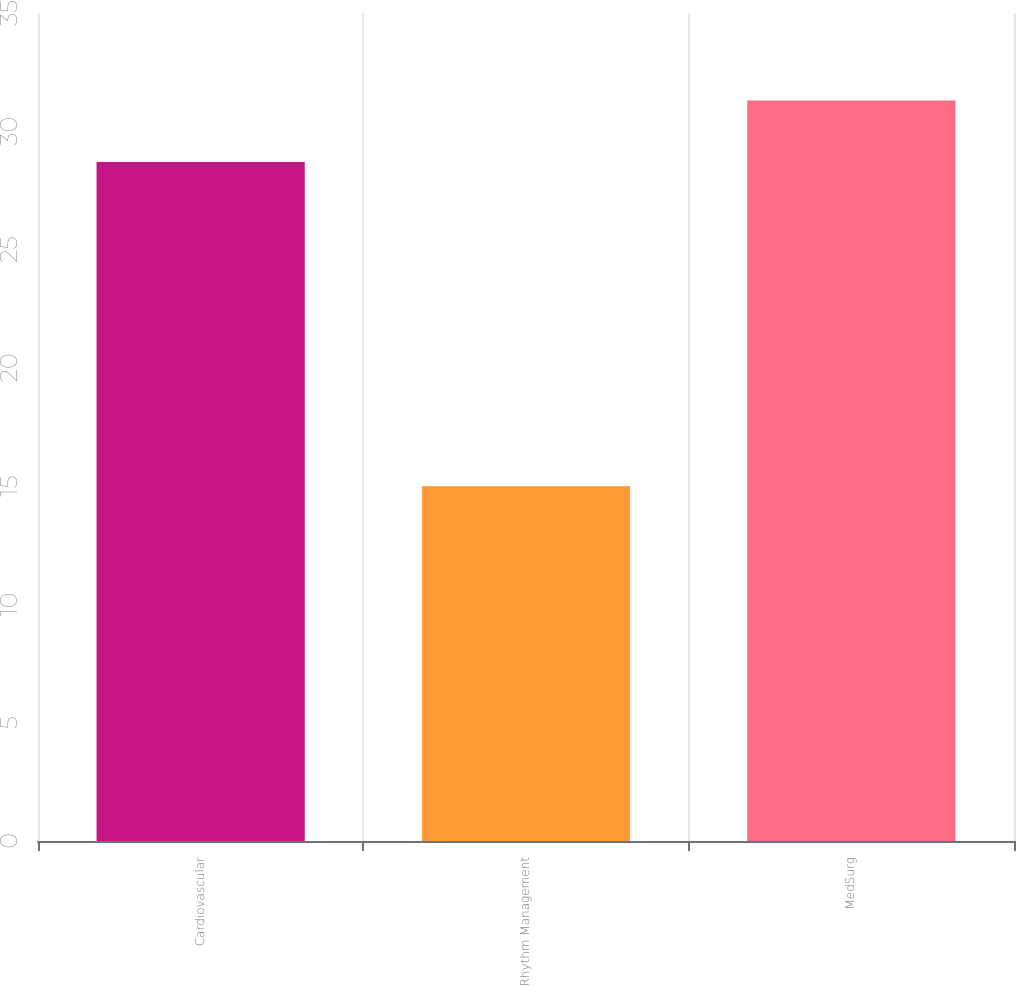<chart> <loc_0><loc_0><loc_500><loc_500><bar_chart><fcel>Cardiovascular<fcel>Rhythm Management<fcel>MedSurg<nl><fcel>28.7<fcel>15<fcel>31.3<nl></chart> 